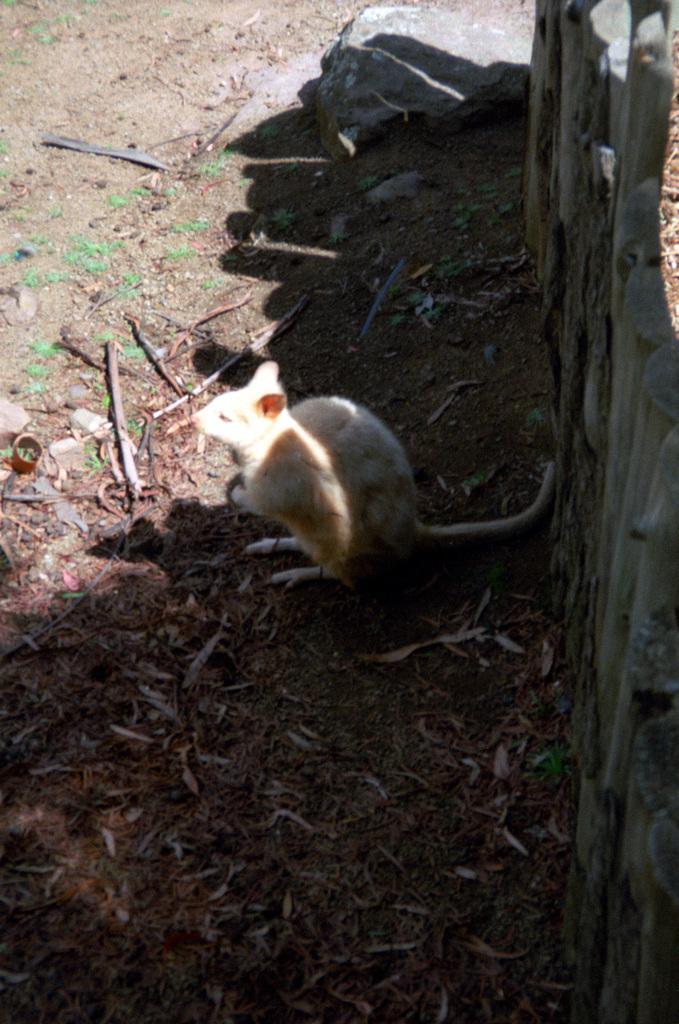Could you give a brief overview of what you see in this image? In this picture there is an animal. At the back there is a stone. On the right side of the image there is a wooden wall. At the bottom there is ground and there are dried leaves and there are sticks. 